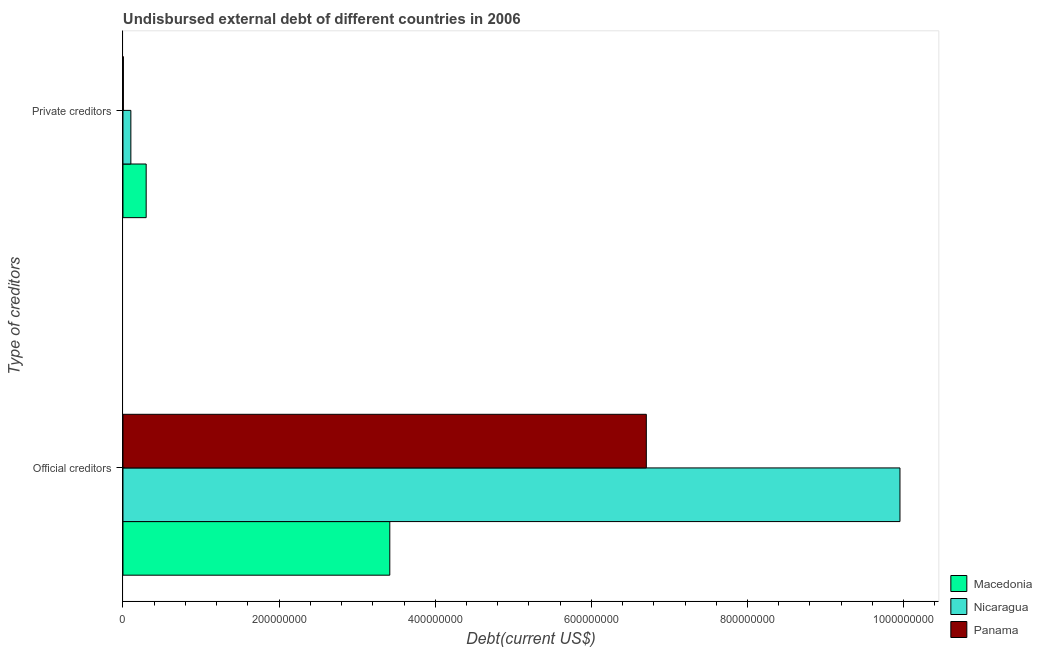How many different coloured bars are there?
Make the answer very short. 3. How many groups of bars are there?
Offer a very short reply. 2. Are the number of bars on each tick of the Y-axis equal?
Keep it short and to the point. Yes. What is the label of the 1st group of bars from the top?
Your response must be concise. Private creditors. What is the undisbursed external debt of official creditors in Macedonia?
Offer a terse response. 3.42e+08. Across all countries, what is the maximum undisbursed external debt of private creditors?
Make the answer very short. 2.97e+07. Across all countries, what is the minimum undisbursed external debt of official creditors?
Provide a short and direct response. 3.42e+08. In which country was the undisbursed external debt of official creditors maximum?
Offer a very short reply. Nicaragua. In which country was the undisbursed external debt of private creditors minimum?
Give a very brief answer. Panama. What is the total undisbursed external debt of official creditors in the graph?
Provide a short and direct response. 2.01e+09. What is the difference between the undisbursed external debt of official creditors in Nicaragua and that in Panama?
Keep it short and to the point. 3.25e+08. What is the difference between the undisbursed external debt of private creditors in Macedonia and the undisbursed external debt of official creditors in Panama?
Your answer should be compact. -6.41e+08. What is the average undisbursed external debt of official creditors per country?
Offer a terse response. 6.69e+08. What is the difference between the undisbursed external debt of official creditors and undisbursed external debt of private creditors in Nicaragua?
Provide a succinct answer. 9.85e+08. In how many countries, is the undisbursed external debt of private creditors greater than 880000000 US$?
Ensure brevity in your answer.  0. What is the ratio of the undisbursed external debt of official creditors in Panama to that in Nicaragua?
Ensure brevity in your answer.  0.67. Is the undisbursed external debt of private creditors in Nicaragua less than that in Panama?
Offer a very short reply. No. In how many countries, is the undisbursed external debt of official creditors greater than the average undisbursed external debt of official creditors taken over all countries?
Your answer should be compact. 2. What does the 3rd bar from the top in Private creditors represents?
Offer a terse response. Macedonia. What does the 1st bar from the bottom in Official creditors represents?
Provide a succinct answer. Macedonia. How many countries are there in the graph?
Offer a terse response. 3. Does the graph contain any zero values?
Your answer should be compact. No. Does the graph contain grids?
Offer a very short reply. No. Where does the legend appear in the graph?
Provide a succinct answer. Bottom right. How many legend labels are there?
Your response must be concise. 3. What is the title of the graph?
Provide a succinct answer. Undisbursed external debt of different countries in 2006. Does "Senegal" appear as one of the legend labels in the graph?
Make the answer very short. No. What is the label or title of the X-axis?
Offer a very short reply. Debt(current US$). What is the label or title of the Y-axis?
Provide a short and direct response. Type of creditors. What is the Debt(current US$) of Macedonia in Official creditors?
Ensure brevity in your answer.  3.42e+08. What is the Debt(current US$) in Nicaragua in Official creditors?
Your response must be concise. 9.95e+08. What is the Debt(current US$) of Panama in Official creditors?
Ensure brevity in your answer.  6.70e+08. What is the Debt(current US$) in Macedonia in Private creditors?
Give a very brief answer. 2.97e+07. What is the Debt(current US$) in Nicaragua in Private creditors?
Ensure brevity in your answer.  1.01e+07. What is the Debt(current US$) of Panama in Private creditors?
Make the answer very short. 4.63e+05. Across all Type of creditors, what is the maximum Debt(current US$) in Macedonia?
Keep it short and to the point. 3.42e+08. Across all Type of creditors, what is the maximum Debt(current US$) of Nicaragua?
Your response must be concise. 9.95e+08. Across all Type of creditors, what is the maximum Debt(current US$) in Panama?
Offer a terse response. 6.70e+08. Across all Type of creditors, what is the minimum Debt(current US$) in Macedonia?
Your response must be concise. 2.97e+07. Across all Type of creditors, what is the minimum Debt(current US$) of Nicaragua?
Your answer should be compact. 1.01e+07. Across all Type of creditors, what is the minimum Debt(current US$) in Panama?
Offer a very short reply. 4.63e+05. What is the total Debt(current US$) in Macedonia in the graph?
Provide a succinct answer. 3.72e+08. What is the total Debt(current US$) of Nicaragua in the graph?
Your response must be concise. 1.01e+09. What is the total Debt(current US$) of Panama in the graph?
Your response must be concise. 6.71e+08. What is the difference between the Debt(current US$) in Macedonia in Official creditors and that in Private creditors?
Give a very brief answer. 3.12e+08. What is the difference between the Debt(current US$) of Nicaragua in Official creditors and that in Private creditors?
Provide a short and direct response. 9.85e+08. What is the difference between the Debt(current US$) of Panama in Official creditors and that in Private creditors?
Make the answer very short. 6.70e+08. What is the difference between the Debt(current US$) in Macedonia in Official creditors and the Debt(current US$) in Nicaragua in Private creditors?
Give a very brief answer. 3.32e+08. What is the difference between the Debt(current US$) in Macedonia in Official creditors and the Debt(current US$) in Panama in Private creditors?
Keep it short and to the point. 3.41e+08. What is the difference between the Debt(current US$) of Nicaragua in Official creditors and the Debt(current US$) of Panama in Private creditors?
Give a very brief answer. 9.95e+08. What is the average Debt(current US$) in Macedonia per Type of creditors?
Provide a succinct answer. 1.86e+08. What is the average Debt(current US$) of Nicaragua per Type of creditors?
Make the answer very short. 5.03e+08. What is the average Debt(current US$) of Panama per Type of creditors?
Make the answer very short. 3.35e+08. What is the difference between the Debt(current US$) in Macedonia and Debt(current US$) in Nicaragua in Official creditors?
Offer a terse response. -6.54e+08. What is the difference between the Debt(current US$) in Macedonia and Debt(current US$) in Panama in Official creditors?
Offer a terse response. -3.29e+08. What is the difference between the Debt(current US$) of Nicaragua and Debt(current US$) of Panama in Official creditors?
Keep it short and to the point. 3.25e+08. What is the difference between the Debt(current US$) of Macedonia and Debt(current US$) of Nicaragua in Private creditors?
Offer a terse response. 1.96e+07. What is the difference between the Debt(current US$) in Macedonia and Debt(current US$) in Panama in Private creditors?
Your answer should be compact. 2.92e+07. What is the difference between the Debt(current US$) of Nicaragua and Debt(current US$) of Panama in Private creditors?
Give a very brief answer. 9.64e+06. What is the ratio of the Debt(current US$) in Macedonia in Official creditors to that in Private creditors?
Offer a terse response. 11.51. What is the ratio of the Debt(current US$) in Nicaragua in Official creditors to that in Private creditors?
Provide a succinct answer. 98.55. What is the ratio of the Debt(current US$) of Panama in Official creditors to that in Private creditors?
Provide a succinct answer. 1448.02. What is the difference between the highest and the second highest Debt(current US$) of Macedonia?
Your answer should be very brief. 3.12e+08. What is the difference between the highest and the second highest Debt(current US$) of Nicaragua?
Keep it short and to the point. 9.85e+08. What is the difference between the highest and the second highest Debt(current US$) in Panama?
Ensure brevity in your answer.  6.70e+08. What is the difference between the highest and the lowest Debt(current US$) of Macedonia?
Offer a terse response. 3.12e+08. What is the difference between the highest and the lowest Debt(current US$) of Nicaragua?
Provide a short and direct response. 9.85e+08. What is the difference between the highest and the lowest Debt(current US$) in Panama?
Your answer should be very brief. 6.70e+08. 